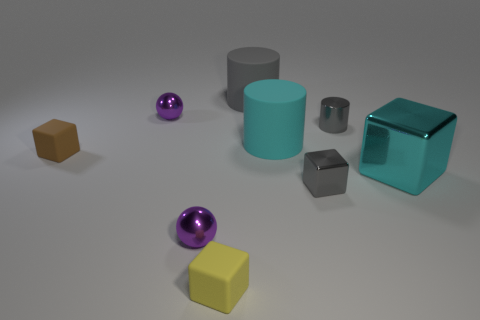Can you tell me what the texture of the objects might feel like? The objects seem to vary in texture: the cylinders and sphere appear smooth and slightly reflective, indicating a possibly metallic or plastic feel, while the cubes look matte, suggesting a rubbery or non-glossy plastic texture. 